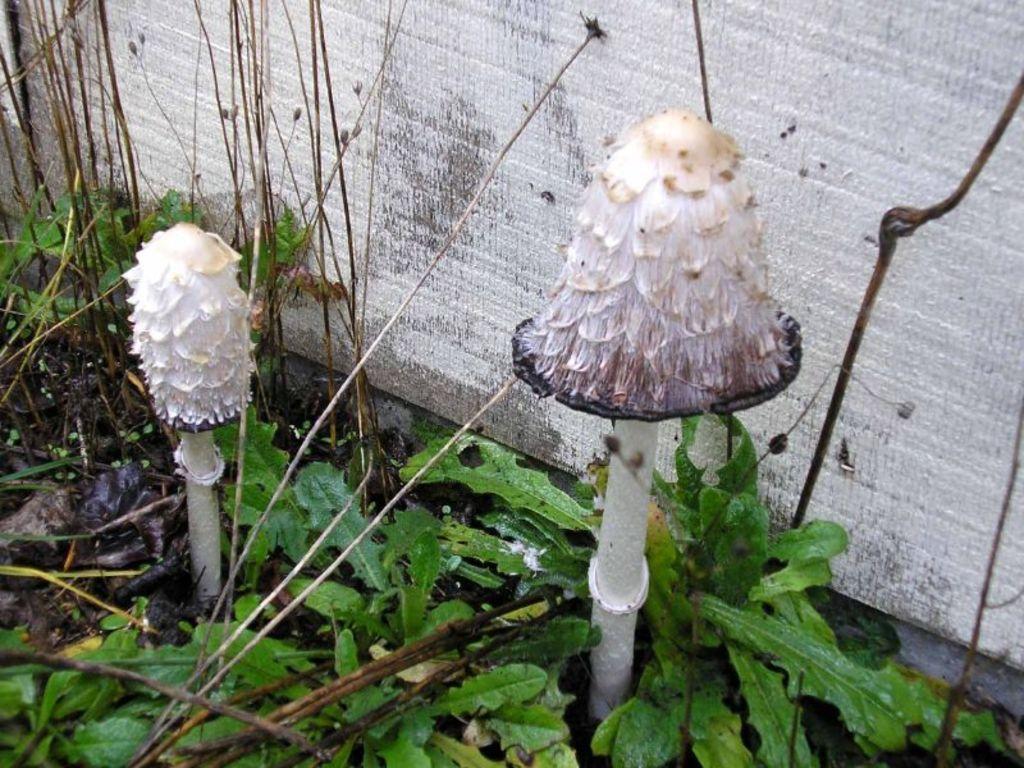How would you summarize this image in a sentence or two? In the center of the image we can see mushrooms and plants. In the background there is wall. 